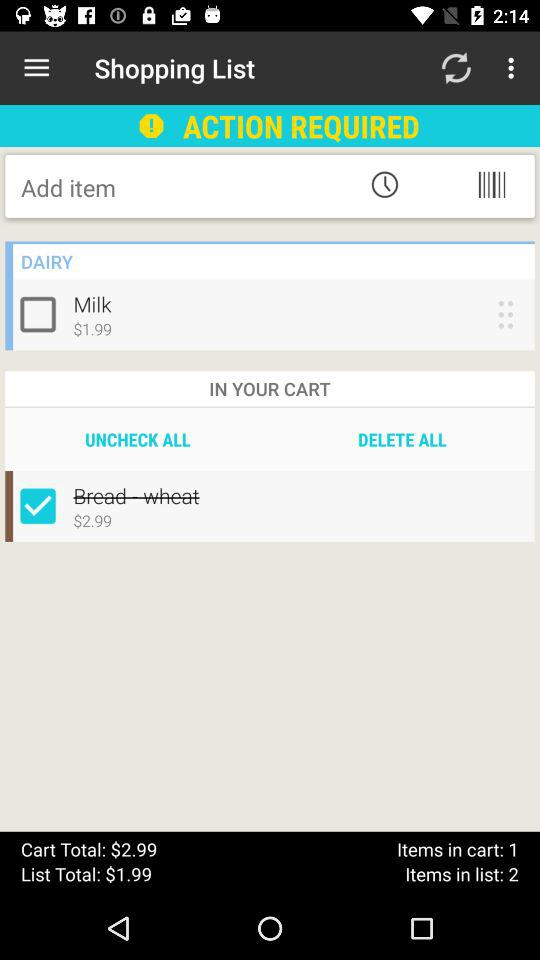What is the total price of the cart? The total price of the cart is $2.99. 